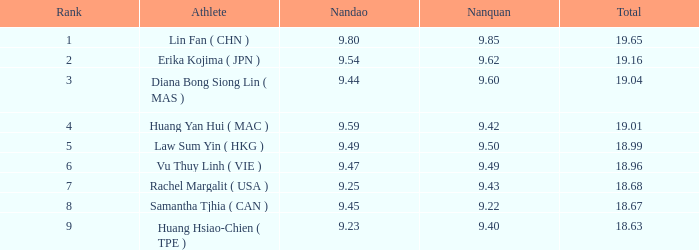68? None. 